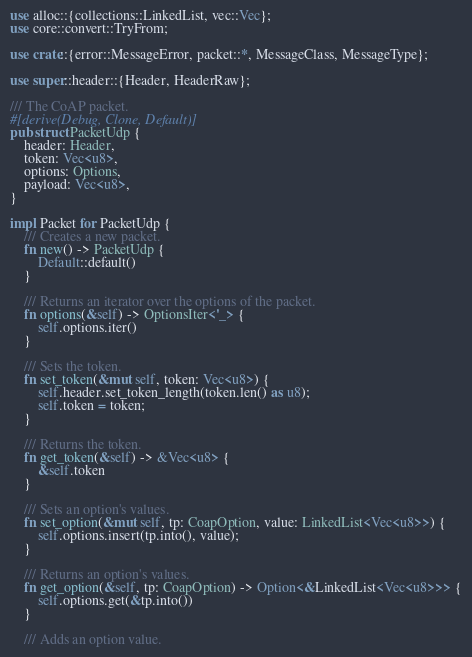Convert code to text. <code><loc_0><loc_0><loc_500><loc_500><_Rust_>use alloc::{collections::LinkedList, vec::Vec};
use core::convert::TryFrom;

use crate::{error::MessageError, packet::*, MessageClass, MessageType};

use super::header::{Header, HeaderRaw};

/// The CoAP packet.
#[derive(Debug, Clone, Default)]
pub struct PacketUdp {
    header: Header,
    token: Vec<u8>,
    options: Options,
    payload: Vec<u8>,
}

impl Packet for PacketUdp {
    /// Creates a new packet.
    fn new() -> PacketUdp {
        Default::default()
    }

    /// Returns an iterator over the options of the packet.
    fn options(&self) -> OptionsIter<'_> {
        self.options.iter()
    }

    /// Sets the token.
    fn set_token(&mut self, token: Vec<u8>) {
        self.header.set_token_length(token.len() as u8);
        self.token = token;
    }

    /// Returns the token.
    fn get_token(&self) -> &Vec<u8> {
        &self.token
    }

    /// Sets an option's values.
    fn set_option(&mut self, tp: CoapOption, value: LinkedList<Vec<u8>>) {
        self.options.insert(tp.into(), value);
    }

    /// Returns an option's values.
    fn get_option(&self, tp: CoapOption) -> Option<&LinkedList<Vec<u8>>> {
        self.options.get(&tp.into())
    }

    /// Adds an option value.</code> 